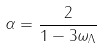Convert formula to latex. <formula><loc_0><loc_0><loc_500><loc_500>\alpha = \frac { 2 } { 1 - 3 \omega _ { \Lambda } }</formula> 